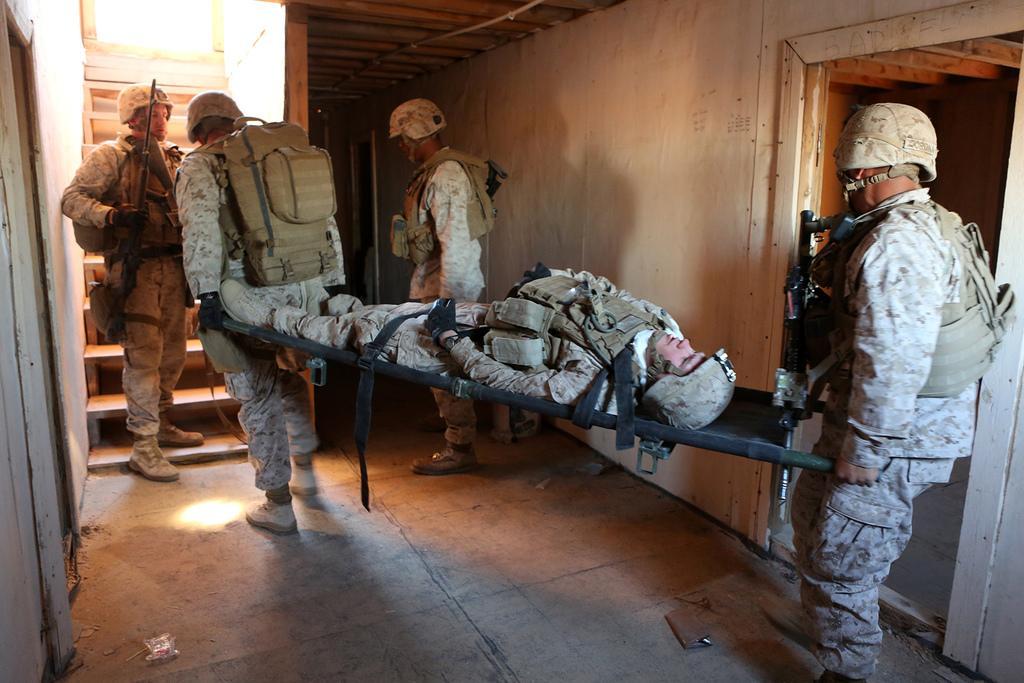Could you give a brief overview of what you see in this image? In this picture we can see five persons wore helmets and standing on the floor where a person lying on a stretcher and in the background we can see wall, steps. 